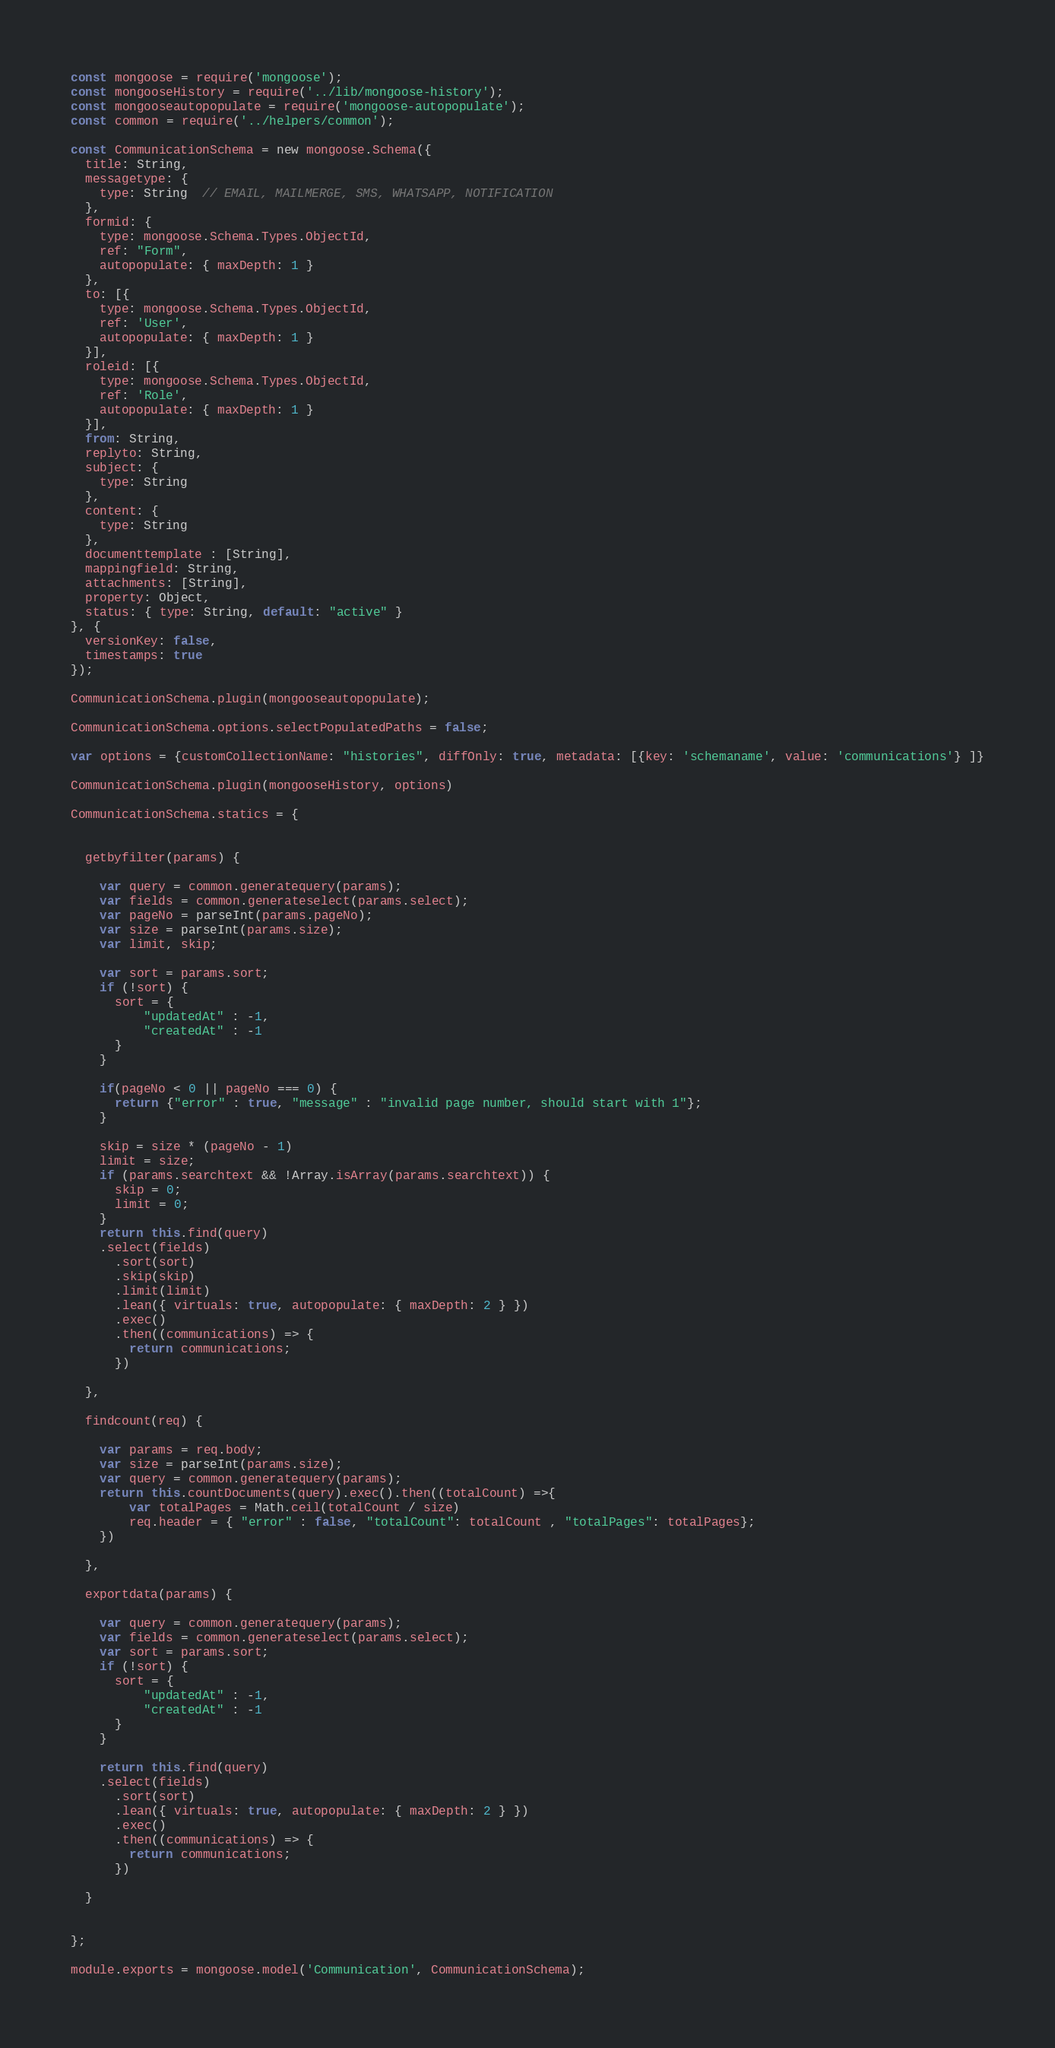<code> <loc_0><loc_0><loc_500><loc_500><_JavaScript_>const mongoose = require('mongoose');
const mongooseHistory = require('../lib/mongoose-history');
const mongooseautopopulate = require('mongoose-autopopulate');
const common = require('../helpers/common');

const CommunicationSchema = new mongoose.Schema({
  title: String,
  messagetype: {
    type: String  // EMAIL, MAILMERGE, SMS, WHATSAPP, NOTIFICATION
  },
  formid: {
    type: mongoose.Schema.Types.ObjectId,
    ref: "Form",
    autopopulate: { maxDepth: 1 }
  },
  to: [{
    type: mongoose.Schema.Types.ObjectId,
    ref: 'User',
    autopopulate: { maxDepth: 1 }
  }],
  roleid: [{
    type: mongoose.Schema.Types.ObjectId,
    ref: 'Role',
    autopopulate: { maxDepth: 1 }
  }],
  from: String,
  replyto: String,
  subject: {
    type: String
  },
  content: {
    type: String
  },
  documenttemplate : [String],
  mappingfield: String,
  attachments: [String],
  property: Object,
  status: { type: String, default: "active" }
}, {
  versionKey: false,
  timestamps: true
});

CommunicationSchema.plugin(mongooseautopopulate);

CommunicationSchema.options.selectPopulatedPaths = false;

var options = {customCollectionName: "histories", diffOnly: true, metadata: [{key: 'schemaname', value: 'communications'} ]}

CommunicationSchema.plugin(mongooseHistory, options)

CommunicationSchema.statics = {


  getbyfilter(params) {

    var query = common.generatequery(params);
    var fields = common.generateselect(params.select);
    var pageNo = parseInt(params.pageNo);
    var size = parseInt(params.size);
    var limit, skip;

    var sort = params.sort;
    if (!sort) {
      sort = {
          "updatedAt" : -1,
          "createdAt" : -1
      }
    }

    if(pageNo < 0 || pageNo === 0) {
      return {"error" : true, "message" : "invalid page number, should start with 1"};
    }

    skip = size * (pageNo - 1)
    limit = size;
    if (params.searchtext && !Array.isArray(params.searchtext)) {
      skip = 0;
      limit = 0;
    }
    return this.find(query)
    .select(fields)
      .sort(sort)
      .skip(skip)
      .limit(limit)
      .lean({ virtuals: true, autopopulate: { maxDepth: 2 } })
      .exec()
      .then((communications) => {
        return communications;
      })

  },

  findcount(req) {

    var params = req.body;
    var size = parseInt(params.size);
    var query = common.generatequery(params);
    return this.countDocuments(query).exec().then((totalCount) =>{
        var totalPages = Math.ceil(totalCount / size)
        req.header = { "error" : false, "totalCount": totalCount , "totalPages": totalPages};
    })

  },

  exportdata(params) {

    var query = common.generatequery(params);
    var fields = common.generateselect(params.select);
    var sort = params.sort;
    if (!sort) {
      sort = {
          "updatedAt" : -1,
          "createdAt" : -1
      }
    }

    return this.find(query)
    .select(fields)
      .sort(sort)
      .lean({ virtuals: true, autopopulate: { maxDepth: 2 } })
      .exec()
      .then((communications) => {
        return communications;
      })

  }


};

module.exports = mongoose.model('Communication', CommunicationSchema);
</code> 